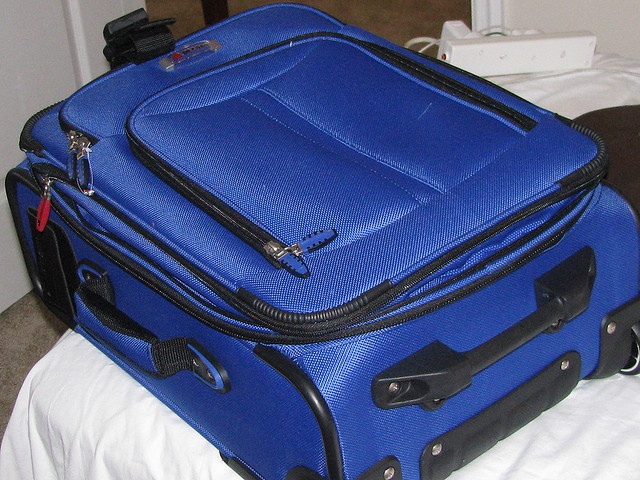Describe the objects in this image and their specific colors. I can see a suitcase in darkgray, blue, black, darkblue, and navy tones in this image. 